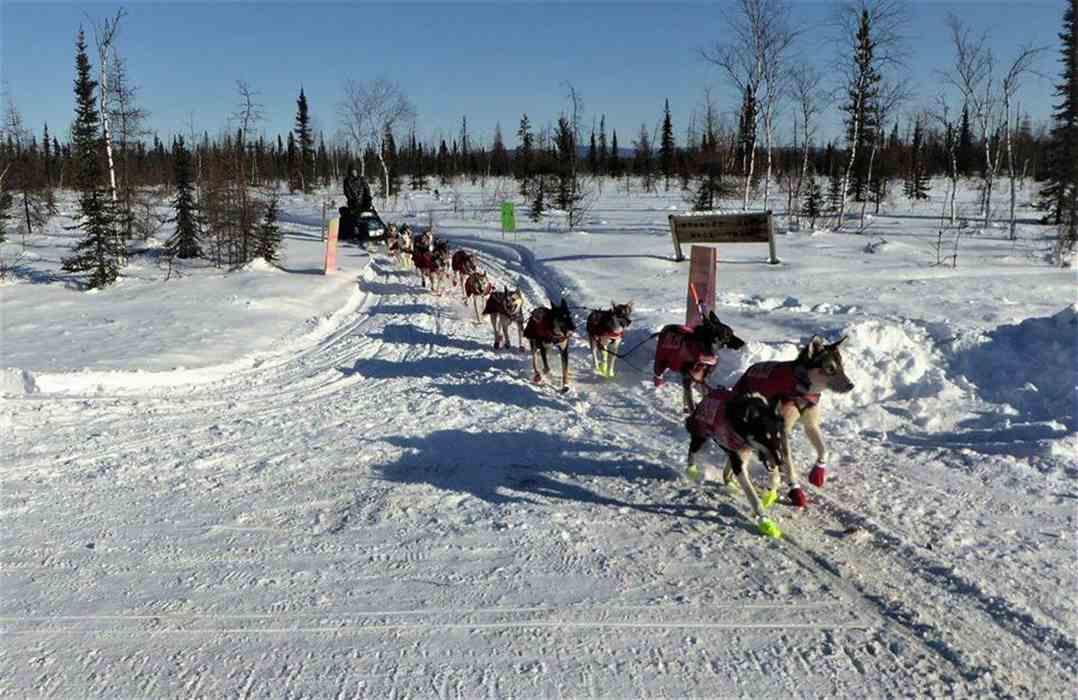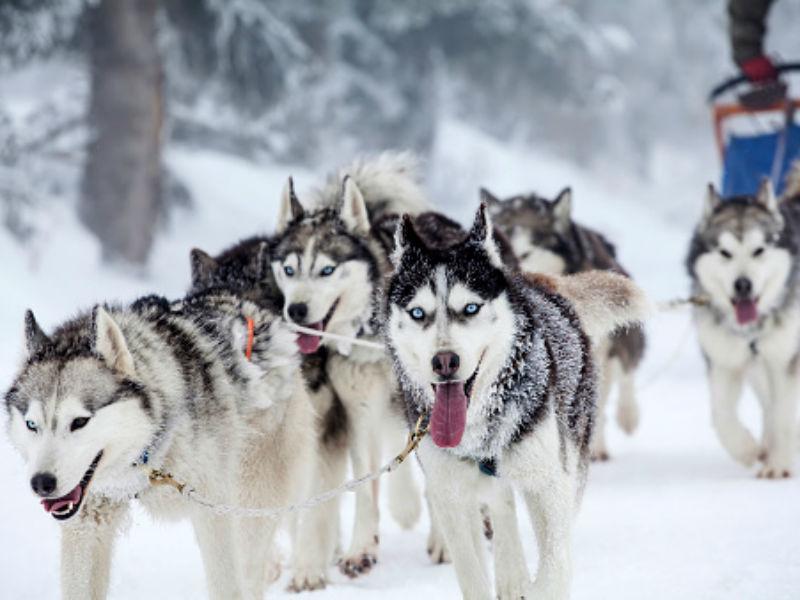The first image is the image on the left, the second image is the image on the right. Analyze the images presented: Is the assertion "Right image shows sled dogs moving rightward, with a mountain backdrop." valid? Answer yes or no. No. 